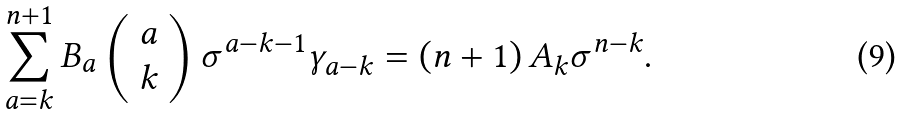<formula> <loc_0><loc_0><loc_500><loc_500>\sum _ { a = k } ^ { n + 1 } B _ { a } \left ( \begin{array} { l } a \\ k \end{array} \right ) \sigma ^ { a - k - 1 } \gamma _ { a - k } = \left ( n + 1 \right ) A _ { k } \sigma ^ { n - k } .</formula> 